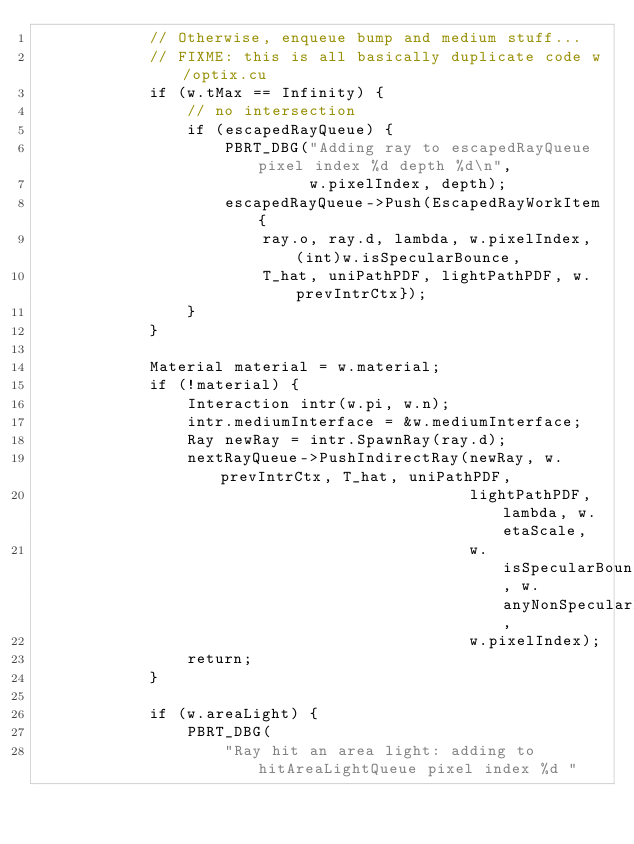Convert code to text. <code><loc_0><loc_0><loc_500><loc_500><_C++_>            // Otherwise, enqueue bump and medium stuff...
            // FIXME: this is all basically duplicate code w/optix.cu
            if (w.tMax == Infinity) {
                // no intersection
                if (escapedRayQueue) {
                    PBRT_DBG("Adding ray to escapedRayQueue pixel index %d depth %d\n",
                             w.pixelIndex, depth);
                    escapedRayQueue->Push(EscapedRayWorkItem{
                        ray.o, ray.d, lambda, w.pixelIndex, (int)w.isSpecularBounce,
                        T_hat, uniPathPDF, lightPathPDF, w.prevIntrCtx});
                }
            }

            Material material = w.material;
            if (!material) {
                Interaction intr(w.pi, w.n);
                intr.mediumInterface = &w.mediumInterface;
                Ray newRay = intr.SpawnRay(ray.d);
                nextRayQueue->PushIndirectRay(newRay, w.prevIntrCtx, T_hat, uniPathPDF,
                                              lightPathPDF, lambda, w.etaScale,
                                              w.isSpecularBounce, w.anyNonSpecularBounces,
                                              w.pixelIndex);
                return;
            }

            if (w.areaLight) {
                PBRT_DBG(
                    "Ray hit an area light: adding to hitAreaLightQueue pixel index %d "</code> 